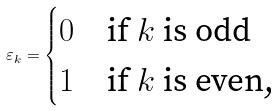<formula> <loc_0><loc_0><loc_500><loc_500>\varepsilon _ { k } = \begin{cases} 0 & \text {if $k$ is odd} \\ 1 & \text {if $k$ is even,} \end{cases}</formula> 